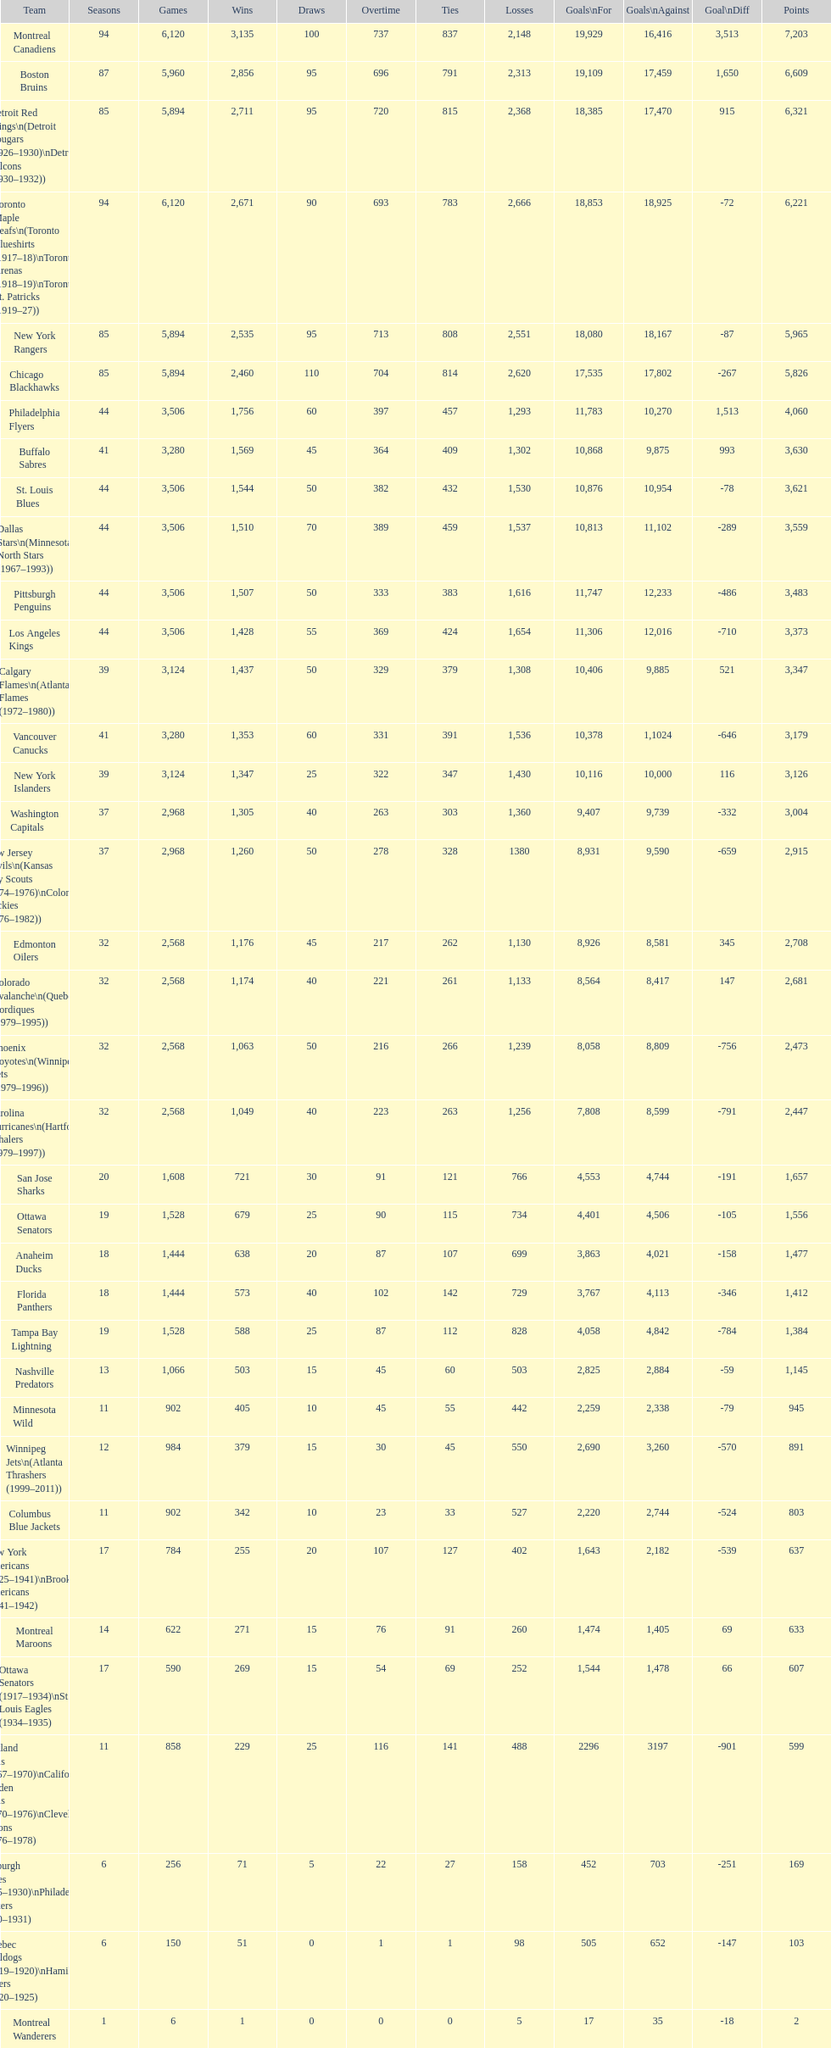What is the number of games that the vancouver canucks have won up to this point? 1,353. 